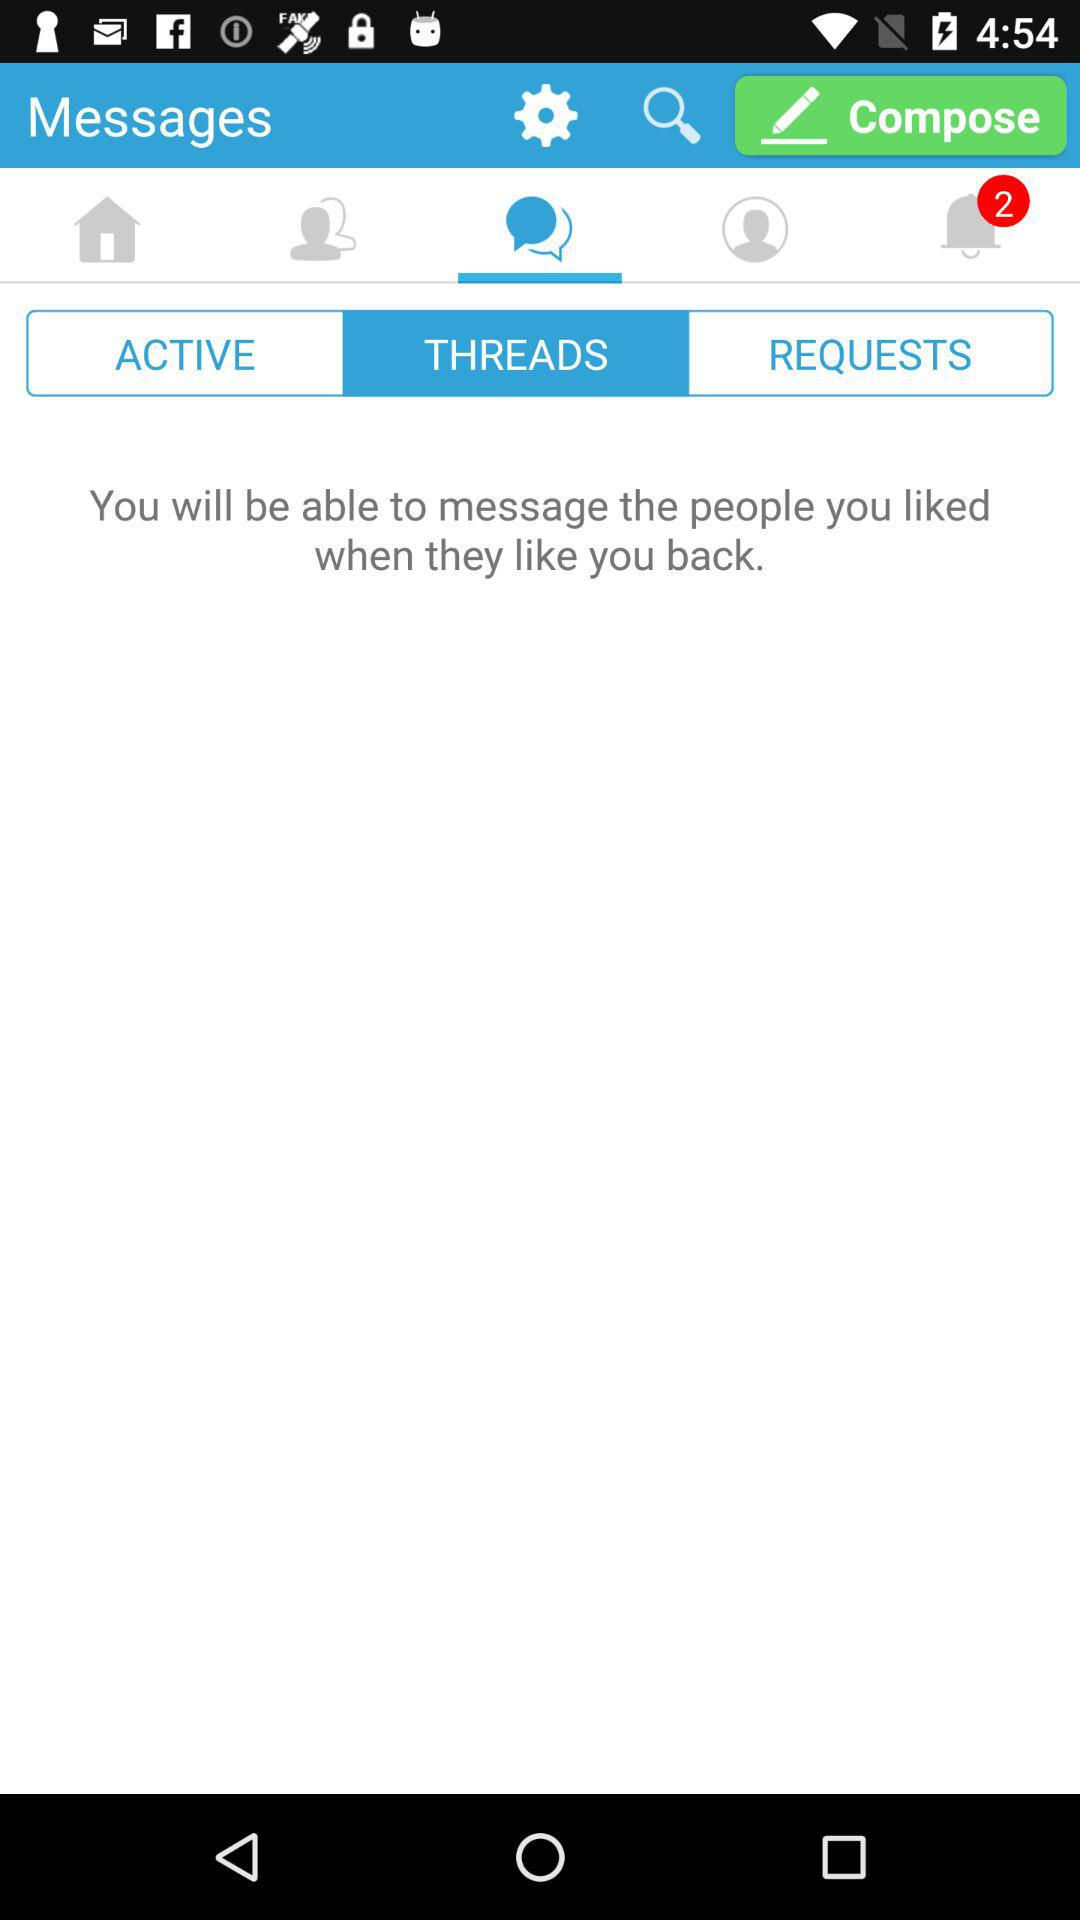Which tab is selected? The selected tabs are "Messages" and "THREADS". 